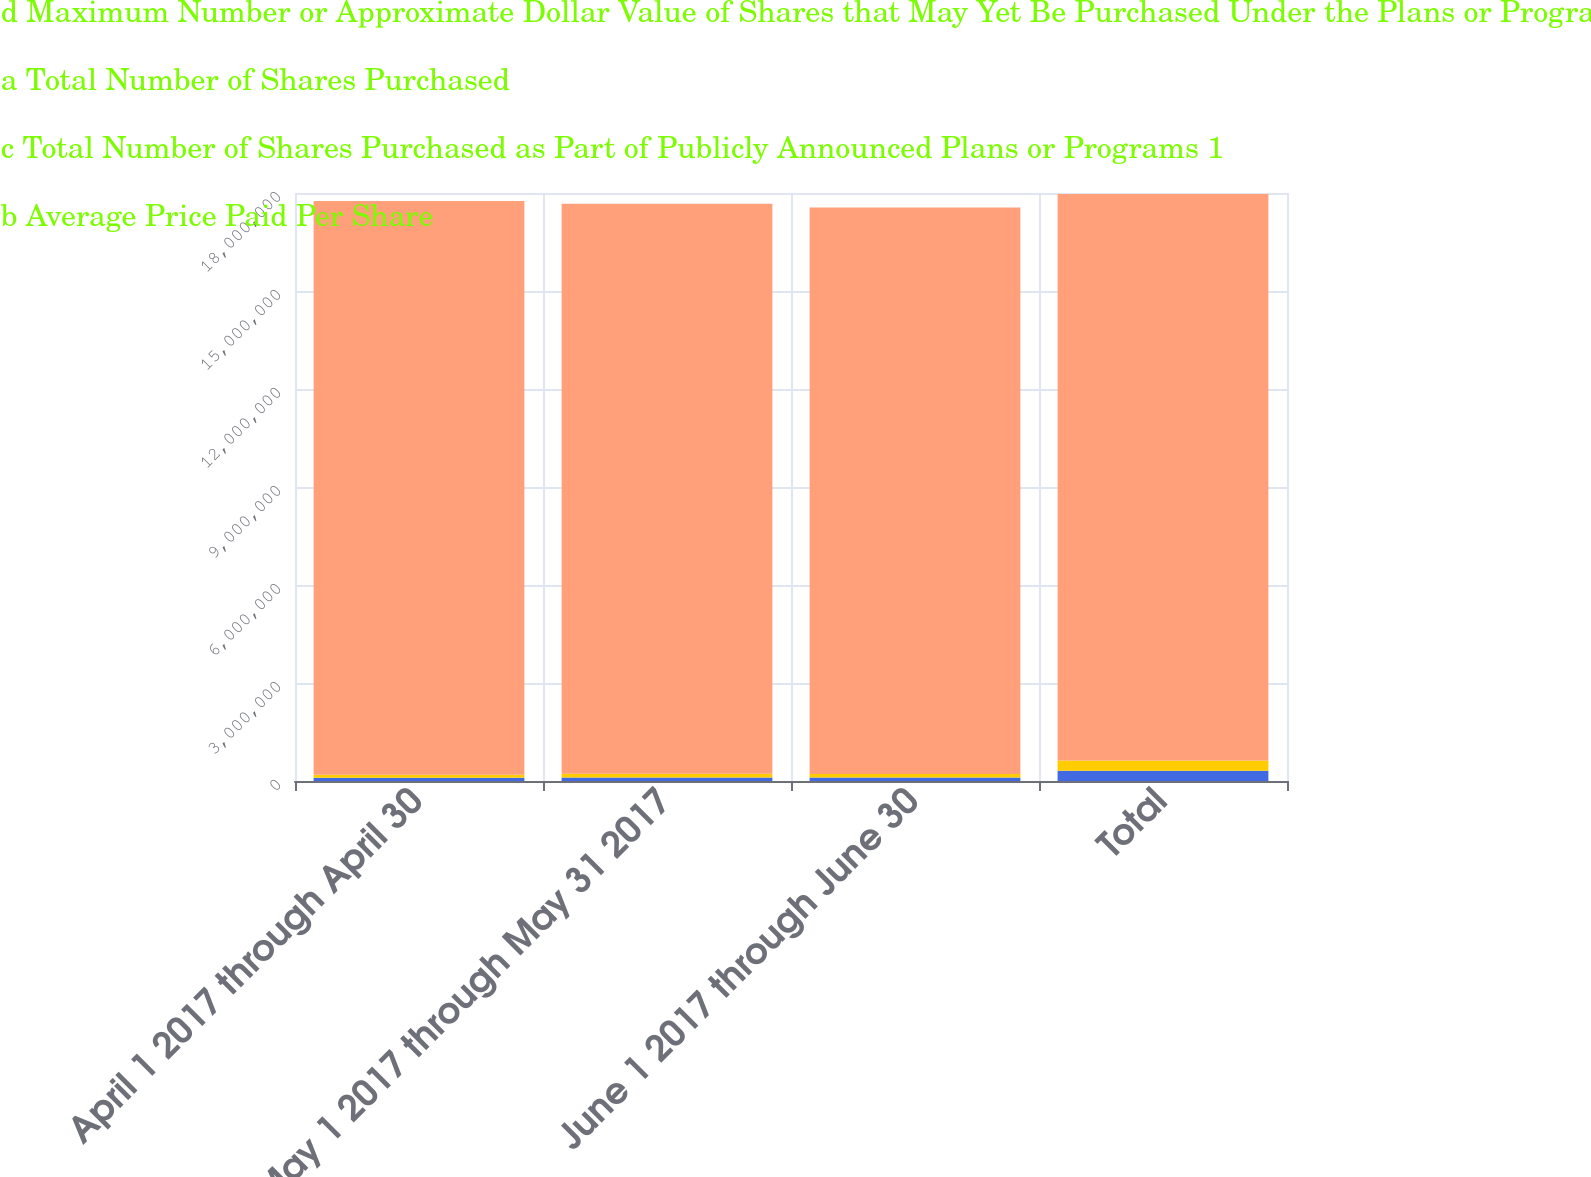Convert chart to OTSL. <chart><loc_0><loc_0><loc_500><loc_500><stacked_bar_chart><ecel><fcel>April 1 2017 through April 30<fcel>May 1 2017 through May 31 2017<fcel>June 1 2017 through June 30<fcel>Total<nl><fcel>d Maximum Number or Approximate Dollar Value of Shares that May Yet Be Purchased Under the Plans or Programs<fcel>96400<fcel>110000<fcel>108919<fcel>315319<nl><fcel>a Total Number of Shares Purchased<fcel>158.85<fcel>158.39<fcel>158.44<fcel>158.55<nl><fcel>c Total Number of Shares Purchased as Part of Publicly Announced Plans or Programs 1<fcel>96400<fcel>110000<fcel>108919<fcel>315319<nl><fcel>b Average Price Paid Per Share<fcel>1.75592e+07<fcel>1.74492e+07<fcel>1.73403e+07<fcel>1.73403e+07<nl></chart> 